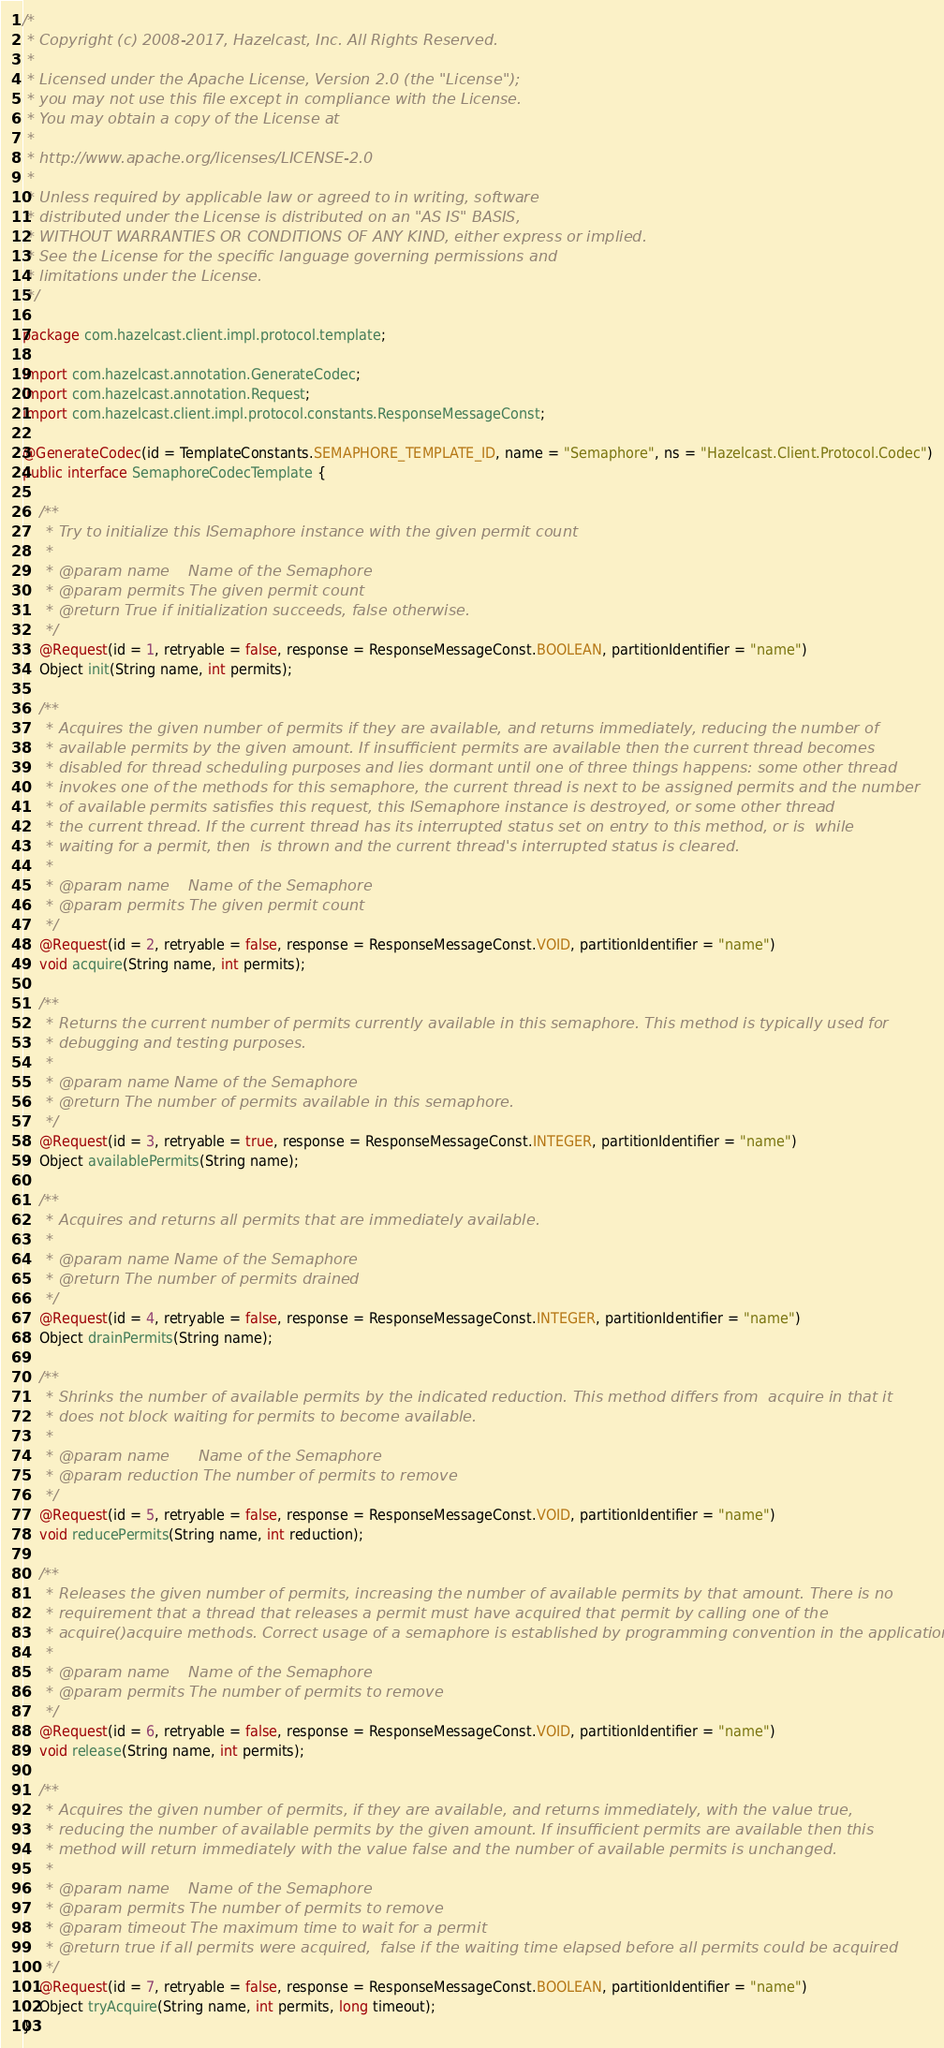Convert code to text. <code><loc_0><loc_0><loc_500><loc_500><_Java_>/*
 * Copyright (c) 2008-2017, Hazelcast, Inc. All Rights Reserved.
 *
 * Licensed under the Apache License, Version 2.0 (the "License");
 * you may not use this file except in compliance with the License.
 * You may obtain a copy of the License at
 *
 * http://www.apache.org/licenses/LICENSE-2.0
 *
 * Unless required by applicable law or agreed to in writing, software
 * distributed under the License is distributed on an "AS IS" BASIS,
 * WITHOUT WARRANTIES OR CONDITIONS OF ANY KIND, either express or implied.
 * See the License for the specific language governing permissions and
 * limitations under the License.
 */

package com.hazelcast.client.impl.protocol.template;

import com.hazelcast.annotation.GenerateCodec;
import com.hazelcast.annotation.Request;
import com.hazelcast.client.impl.protocol.constants.ResponseMessageConst;

@GenerateCodec(id = TemplateConstants.SEMAPHORE_TEMPLATE_ID, name = "Semaphore", ns = "Hazelcast.Client.Protocol.Codec")
public interface SemaphoreCodecTemplate {

    /**
     * Try to initialize this ISemaphore instance with the given permit count
     *
     * @param name    Name of the Semaphore
     * @param permits The given permit count
     * @return True if initialization succeeds, false otherwise.
     */
    @Request(id = 1, retryable = false, response = ResponseMessageConst.BOOLEAN, partitionIdentifier = "name")
    Object init(String name, int permits);

    /**
     * Acquires the given number of permits if they are available, and returns immediately, reducing the number of
     * available permits by the given amount. If insufficient permits are available then the current thread becomes
     * disabled for thread scheduling purposes and lies dormant until one of three things happens: some other thread
     * invokes one of the methods for this semaphore, the current thread is next to be assigned permits and the number
     * of available permits satisfies this request, this ISemaphore instance is destroyed, or some other thread
     * the current thread. If the current thread has its interrupted status set on entry to this method, or is  while
     * waiting for a permit, then  is thrown and the current thread's interrupted status is cleared.
     *
     * @param name    Name of the Semaphore
     * @param permits The given permit count
     */
    @Request(id = 2, retryable = false, response = ResponseMessageConst.VOID, partitionIdentifier = "name")
    void acquire(String name, int permits);

    /**
     * Returns the current number of permits currently available in this semaphore. This method is typically used for
     * debugging and testing purposes.
     *
     * @param name Name of the Semaphore
     * @return The number of permits available in this semaphore.
     */
    @Request(id = 3, retryable = true, response = ResponseMessageConst.INTEGER, partitionIdentifier = "name")
    Object availablePermits(String name);

    /**
     * Acquires and returns all permits that are immediately available.
     *
     * @param name Name of the Semaphore
     * @return The number of permits drained
     */
    @Request(id = 4, retryable = false, response = ResponseMessageConst.INTEGER, partitionIdentifier = "name")
    Object drainPermits(String name);

    /**
     * Shrinks the number of available permits by the indicated reduction. This method differs from  acquire in that it
     * does not block waiting for permits to become available.
     *
     * @param name      Name of the Semaphore
     * @param reduction The number of permits to remove
     */
    @Request(id = 5, retryable = false, response = ResponseMessageConst.VOID, partitionIdentifier = "name")
    void reducePermits(String name, int reduction);

    /**
     * Releases the given number of permits, increasing the number of available permits by that amount. There is no
     * requirement that a thread that releases a permit must have acquired that permit by calling one of the
     * acquire()acquire methods. Correct usage of a semaphore is established by programming convention in the application.
     *
     * @param name    Name of the Semaphore
     * @param permits The number of permits to remove
     */
    @Request(id = 6, retryable = false, response = ResponseMessageConst.VOID, partitionIdentifier = "name")
    void release(String name, int permits);

    /**
     * Acquires the given number of permits, if they are available, and returns immediately, with the value true,
     * reducing the number of available permits by the given amount. If insufficient permits are available then this
     * method will return immediately with the value false and the number of available permits is unchanged.
     *
     * @param name    Name of the Semaphore
     * @param permits The number of permits to remove
     * @param timeout The maximum time to wait for a permit
     * @return true if all permits were acquired,  false if the waiting time elapsed before all permits could be acquired
     */
    @Request(id = 7, retryable = false, response = ResponseMessageConst.BOOLEAN, partitionIdentifier = "name")
    Object tryAcquire(String name, int permits, long timeout);
}
</code> 